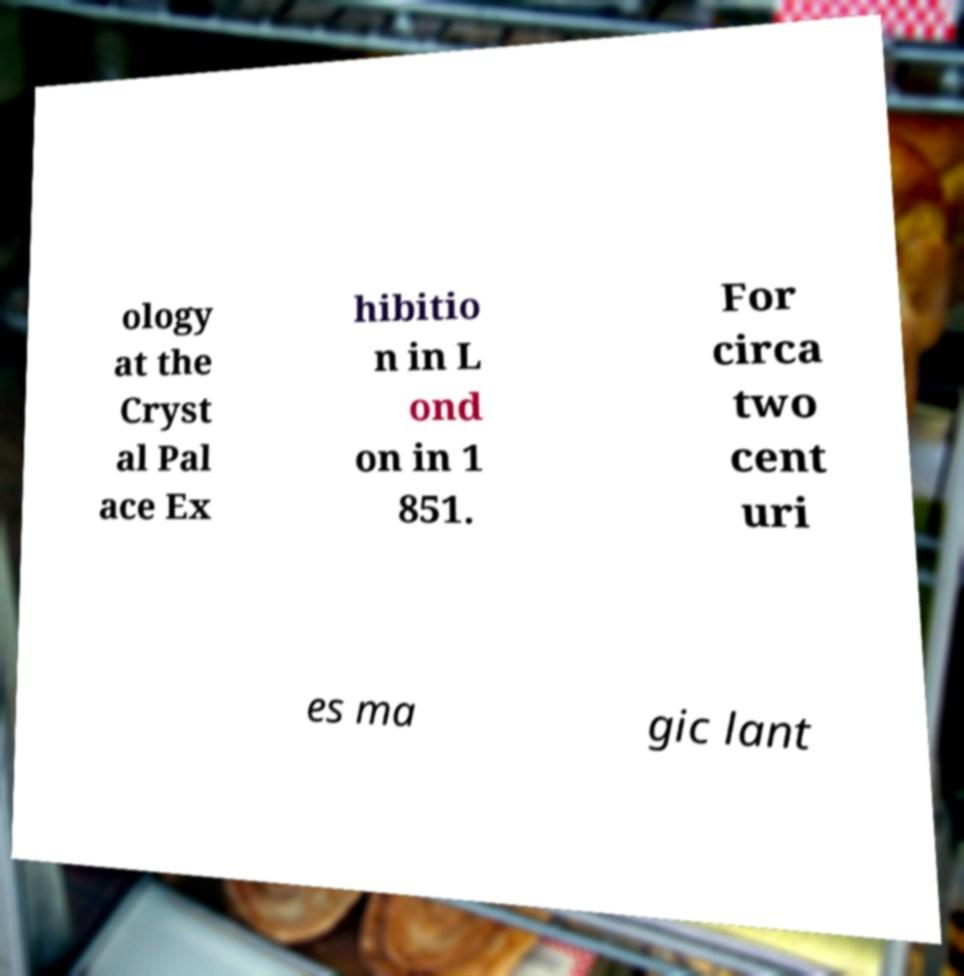There's text embedded in this image that I need extracted. Can you transcribe it verbatim? ology at the Cryst al Pal ace Ex hibitio n in L ond on in 1 851. For circa two cent uri es ma gic lant 